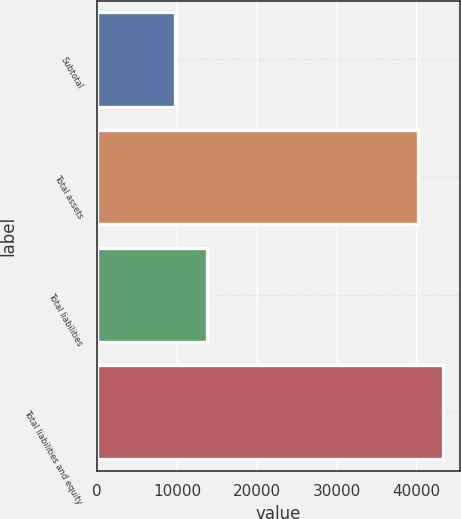<chart> <loc_0><loc_0><loc_500><loc_500><bar_chart><fcel>Subtotal<fcel>Total assets<fcel>Total liabilities<fcel>Total liabilities and equity<nl><fcel>9777<fcel>40258<fcel>13820<fcel>43306.1<nl></chart> 